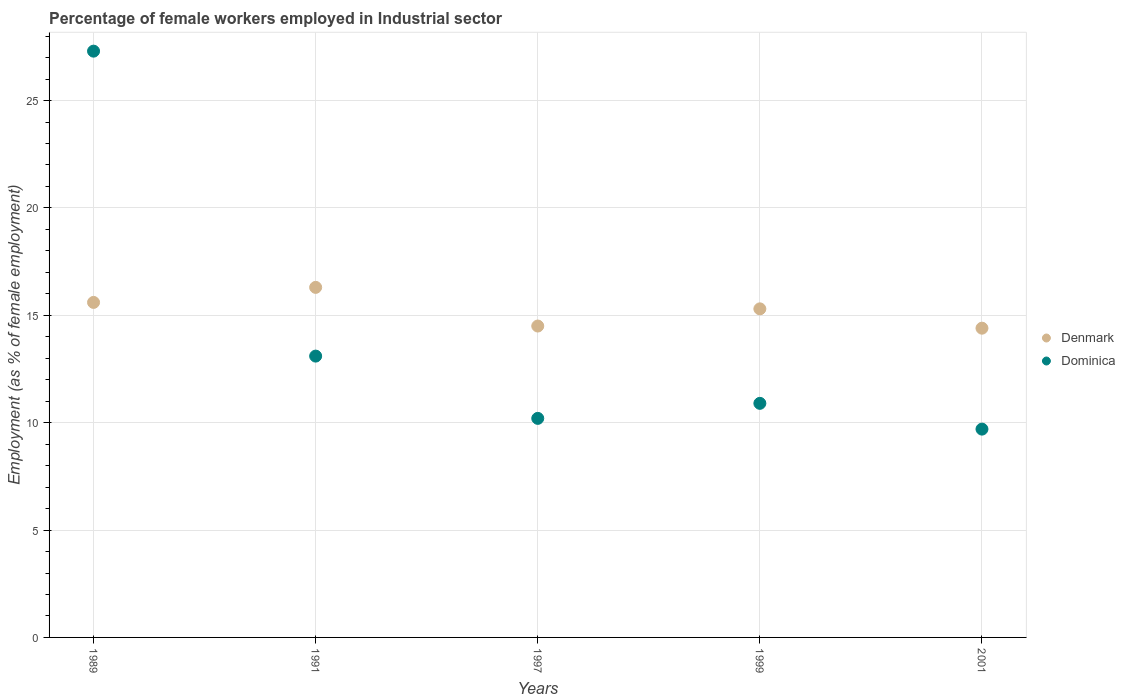How many different coloured dotlines are there?
Your response must be concise. 2. What is the percentage of females employed in Industrial sector in Denmark in 1991?
Offer a terse response. 16.3. Across all years, what is the maximum percentage of females employed in Industrial sector in Dominica?
Make the answer very short. 27.3. Across all years, what is the minimum percentage of females employed in Industrial sector in Denmark?
Your response must be concise. 14.4. In which year was the percentage of females employed in Industrial sector in Denmark minimum?
Your response must be concise. 2001. What is the total percentage of females employed in Industrial sector in Dominica in the graph?
Give a very brief answer. 71.2. What is the difference between the percentage of females employed in Industrial sector in Denmark in 1989 and that in 1991?
Give a very brief answer. -0.7. What is the difference between the percentage of females employed in Industrial sector in Dominica in 1989 and the percentage of females employed in Industrial sector in Denmark in 1997?
Provide a succinct answer. 12.8. What is the average percentage of females employed in Industrial sector in Dominica per year?
Offer a terse response. 14.24. In the year 1989, what is the difference between the percentage of females employed in Industrial sector in Denmark and percentage of females employed in Industrial sector in Dominica?
Your answer should be very brief. -11.7. In how many years, is the percentage of females employed in Industrial sector in Dominica greater than 27 %?
Offer a terse response. 1. What is the ratio of the percentage of females employed in Industrial sector in Dominica in 1989 to that in 2001?
Your answer should be compact. 2.81. Is the percentage of females employed in Industrial sector in Dominica in 1991 less than that in 2001?
Your answer should be very brief. No. What is the difference between the highest and the second highest percentage of females employed in Industrial sector in Denmark?
Offer a very short reply. 0.7. What is the difference between the highest and the lowest percentage of females employed in Industrial sector in Denmark?
Provide a succinct answer. 1.9. In how many years, is the percentage of females employed in Industrial sector in Dominica greater than the average percentage of females employed in Industrial sector in Dominica taken over all years?
Your answer should be compact. 1. Does the percentage of females employed in Industrial sector in Dominica monotonically increase over the years?
Ensure brevity in your answer.  No. Is the percentage of females employed in Industrial sector in Denmark strictly greater than the percentage of females employed in Industrial sector in Dominica over the years?
Keep it short and to the point. No. How many dotlines are there?
Your answer should be compact. 2. How many years are there in the graph?
Provide a succinct answer. 5. What is the title of the graph?
Your response must be concise. Percentage of female workers employed in Industrial sector. What is the label or title of the Y-axis?
Provide a succinct answer. Employment (as % of female employment). What is the Employment (as % of female employment) of Denmark in 1989?
Your response must be concise. 15.6. What is the Employment (as % of female employment) in Dominica in 1989?
Offer a very short reply. 27.3. What is the Employment (as % of female employment) of Denmark in 1991?
Keep it short and to the point. 16.3. What is the Employment (as % of female employment) in Dominica in 1991?
Provide a short and direct response. 13.1. What is the Employment (as % of female employment) of Dominica in 1997?
Keep it short and to the point. 10.2. What is the Employment (as % of female employment) of Denmark in 1999?
Your answer should be very brief. 15.3. What is the Employment (as % of female employment) of Dominica in 1999?
Provide a short and direct response. 10.9. What is the Employment (as % of female employment) of Denmark in 2001?
Ensure brevity in your answer.  14.4. What is the Employment (as % of female employment) in Dominica in 2001?
Make the answer very short. 9.7. Across all years, what is the maximum Employment (as % of female employment) of Denmark?
Your answer should be very brief. 16.3. Across all years, what is the maximum Employment (as % of female employment) in Dominica?
Your answer should be compact. 27.3. Across all years, what is the minimum Employment (as % of female employment) of Denmark?
Your response must be concise. 14.4. Across all years, what is the minimum Employment (as % of female employment) of Dominica?
Ensure brevity in your answer.  9.7. What is the total Employment (as % of female employment) in Denmark in the graph?
Your answer should be compact. 76.1. What is the total Employment (as % of female employment) in Dominica in the graph?
Your answer should be very brief. 71.2. What is the difference between the Employment (as % of female employment) in Denmark in 1989 and that in 1991?
Keep it short and to the point. -0.7. What is the difference between the Employment (as % of female employment) in Dominica in 1989 and that in 1997?
Make the answer very short. 17.1. What is the difference between the Employment (as % of female employment) of Denmark in 1989 and that in 1999?
Your answer should be compact. 0.3. What is the difference between the Employment (as % of female employment) in Denmark in 1991 and that in 1999?
Your answer should be very brief. 1. What is the difference between the Employment (as % of female employment) in Dominica in 1991 and that in 1999?
Offer a terse response. 2.2. What is the difference between the Employment (as % of female employment) of Dominica in 1991 and that in 2001?
Ensure brevity in your answer.  3.4. What is the difference between the Employment (as % of female employment) in Denmark in 1997 and that in 1999?
Your answer should be very brief. -0.8. What is the difference between the Employment (as % of female employment) in Denmark in 1997 and that in 2001?
Your response must be concise. 0.1. What is the difference between the Employment (as % of female employment) of Denmark in 1989 and the Employment (as % of female employment) of Dominica in 1991?
Your response must be concise. 2.5. What is the difference between the Employment (as % of female employment) in Denmark in 1989 and the Employment (as % of female employment) in Dominica in 1997?
Offer a very short reply. 5.4. What is the difference between the Employment (as % of female employment) in Denmark in 1991 and the Employment (as % of female employment) in Dominica in 1997?
Provide a short and direct response. 6.1. What is the difference between the Employment (as % of female employment) in Denmark in 1991 and the Employment (as % of female employment) in Dominica in 1999?
Offer a very short reply. 5.4. What is the difference between the Employment (as % of female employment) in Denmark in 1991 and the Employment (as % of female employment) in Dominica in 2001?
Ensure brevity in your answer.  6.6. What is the difference between the Employment (as % of female employment) of Denmark in 1999 and the Employment (as % of female employment) of Dominica in 2001?
Give a very brief answer. 5.6. What is the average Employment (as % of female employment) in Denmark per year?
Offer a very short reply. 15.22. What is the average Employment (as % of female employment) in Dominica per year?
Your answer should be very brief. 14.24. In the year 1991, what is the difference between the Employment (as % of female employment) in Denmark and Employment (as % of female employment) in Dominica?
Ensure brevity in your answer.  3.2. In the year 1999, what is the difference between the Employment (as % of female employment) of Denmark and Employment (as % of female employment) of Dominica?
Offer a terse response. 4.4. In the year 2001, what is the difference between the Employment (as % of female employment) of Denmark and Employment (as % of female employment) of Dominica?
Your answer should be very brief. 4.7. What is the ratio of the Employment (as % of female employment) in Denmark in 1989 to that in 1991?
Your response must be concise. 0.96. What is the ratio of the Employment (as % of female employment) of Dominica in 1989 to that in 1991?
Provide a succinct answer. 2.08. What is the ratio of the Employment (as % of female employment) of Denmark in 1989 to that in 1997?
Ensure brevity in your answer.  1.08. What is the ratio of the Employment (as % of female employment) in Dominica in 1989 to that in 1997?
Keep it short and to the point. 2.68. What is the ratio of the Employment (as % of female employment) of Denmark in 1989 to that in 1999?
Provide a succinct answer. 1.02. What is the ratio of the Employment (as % of female employment) in Dominica in 1989 to that in 1999?
Your answer should be compact. 2.5. What is the ratio of the Employment (as % of female employment) in Dominica in 1989 to that in 2001?
Your answer should be compact. 2.81. What is the ratio of the Employment (as % of female employment) in Denmark in 1991 to that in 1997?
Make the answer very short. 1.12. What is the ratio of the Employment (as % of female employment) of Dominica in 1991 to that in 1997?
Offer a very short reply. 1.28. What is the ratio of the Employment (as % of female employment) in Denmark in 1991 to that in 1999?
Your response must be concise. 1.07. What is the ratio of the Employment (as % of female employment) of Dominica in 1991 to that in 1999?
Offer a very short reply. 1.2. What is the ratio of the Employment (as % of female employment) of Denmark in 1991 to that in 2001?
Offer a terse response. 1.13. What is the ratio of the Employment (as % of female employment) in Dominica in 1991 to that in 2001?
Your answer should be very brief. 1.35. What is the ratio of the Employment (as % of female employment) in Denmark in 1997 to that in 1999?
Provide a short and direct response. 0.95. What is the ratio of the Employment (as % of female employment) of Dominica in 1997 to that in 1999?
Offer a very short reply. 0.94. What is the ratio of the Employment (as % of female employment) in Denmark in 1997 to that in 2001?
Your answer should be very brief. 1.01. What is the ratio of the Employment (as % of female employment) in Dominica in 1997 to that in 2001?
Your answer should be very brief. 1.05. What is the ratio of the Employment (as % of female employment) of Dominica in 1999 to that in 2001?
Make the answer very short. 1.12. 